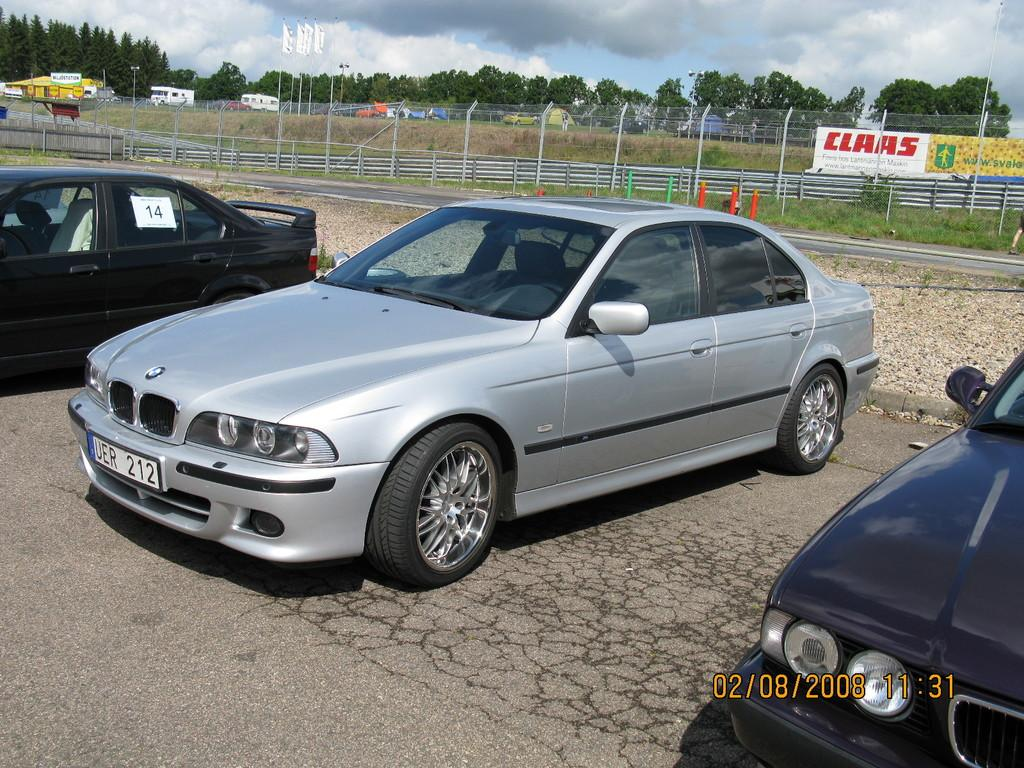What can be seen moving on the road in the image? There are cars on the road in the image. What type of structures are present alongside the road? There are fences in the image. What are the banners used for in the image? The purpose of the banners in the image is not specified, but they are likely used for advertising or announcements. What type of vegetation is present in the image? There are trees in the image. What other structures can be seen in the image? There are poles in the image. What is visible in the background of the image? The sky with clouds is visible in the background of the image. What type of bread can be seen hanging from the trees in the image? There is no bread present in the image; it features cars on the road, fences, banners, trees, poles, and a sky with clouds. How does the division between the cars and the trees affect the image? The image does not depict any division between the cars and the trees; it shows them coexisting in the same scene. 